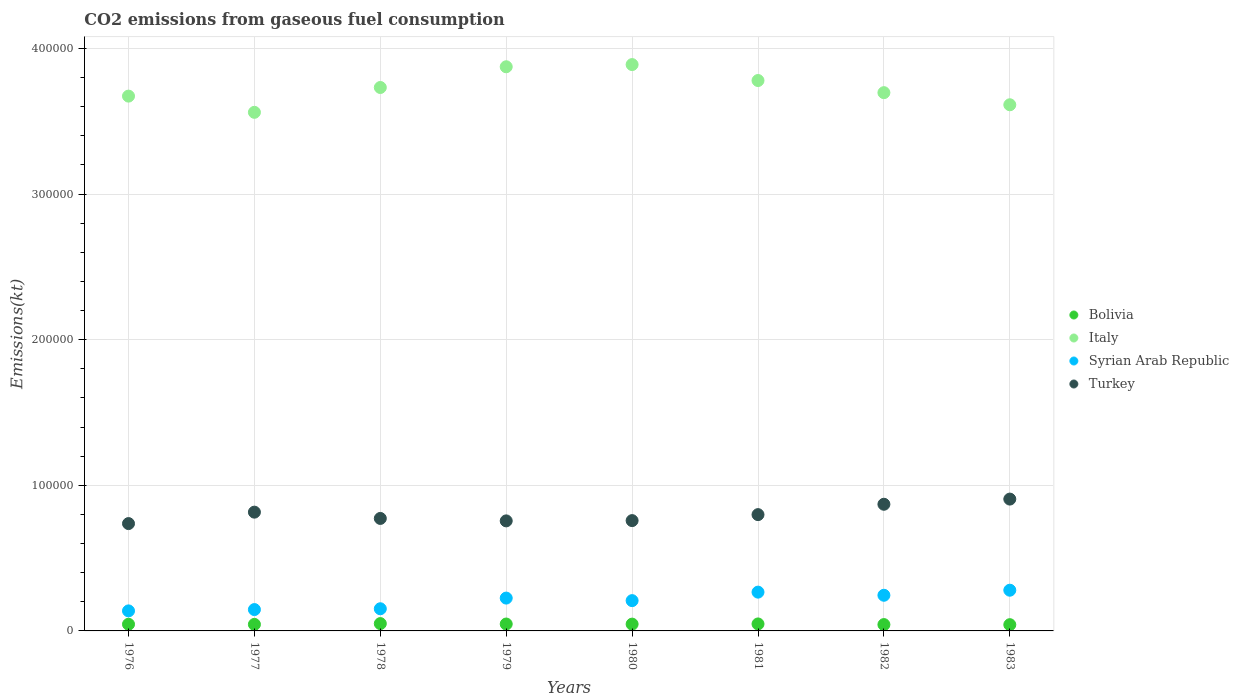How many different coloured dotlines are there?
Your response must be concise. 4. What is the amount of CO2 emitted in Italy in 1978?
Give a very brief answer. 3.73e+05. Across all years, what is the maximum amount of CO2 emitted in Syrian Arab Republic?
Your answer should be very brief. 2.80e+04. Across all years, what is the minimum amount of CO2 emitted in Syrian Arab Republic?
Ensure brevity in your answer.  1.38e+04. In which year was the amount of CO2 emitted in Bolivia maximum?
Provide a short and direct response. 1978. In which year was the amount of CO2 emitted in Syrian Arab Republic minimum?
Offer a very short reply. 1976. What is the total amount of CO2 emitted in Turkey in the graph?
Keep it short and to the point. 6.41e+05. What is the difference between the amount of CO2 emitted in Italy in 1976 and that in 1982?
Give a very brief answer. -2368.88. What is the difference between the amount of CO2 emitted in Turkey in 1976 and the amount of CO2 emitted in Syrian Arab Republic in 1980?
Your response must be concise. 5.29e+04. What is the average amount of CO2 emitted in Italy per year?
Ensure brevity in your answer.  3.73e+05. In the year 1976, what is the difference between the amount of CO2 emitted in Italy and amount of CO2 emitted in Turkey?
Provide a succinct answer. 2.94e+05. In how many years, is the amount of CO2 emitted in Italy greater than 160000 kt?
Your answer should be compact. 8. What is the ratio of the amount of CO2 emitted in Italy in 1976 to that in 1977?
Your answer should be compact. 1.03. Is the amount of CO2 emitted in Italy in 1978 less than that in 1980?
Provide a short and direct response. Yes. Is the difference between the amount of CO2 emitted in Italy in 1976 and 1982 greater than the difference between the amount of CO2 emitted in Turkey in 1976 and 1982?
Your answer should be very brief. Yes. What is the difference between the highest and the second highest amount of CO2 emitted in Bolivia?
Ensure brevity in your answer.  234.69. What is the difference between the highest and the lowest amount of CO2 emitted in Bolivia?
Offer a very short reply. 737.07. In how many years, is the amount of CO2 emitted in Bolivia greater than the average amount of CO2 emitted in Bolivia taken over all years?
Offer a terse response. 4. Is the sum of the amount of CO2 emitted in Bolivia in 1977 and 1983 greater than the maximum amount of CO2 emitted in Turkey across all years?
Your answer should be compact. No. Is it the case that in every year, the sum of the amount of CO2 emitted in Italy and amount of CO2 emitted in Turkey  is greater than the amount of CO2 emitted in Bolivia?
Provide a succinct answer. Yes. Does the amount of CO2 emitted in Syrian Arab Republic monotonically increase over the years?
Provide a succinct answer. No. Is the amount of CO2 emitted in Italy strictly less than the amount of CO2 emitted in Bolivia over the years?
Keep it short and to the point. No. How many dotlines are there?
Offer a very short reply. 4. What is the difference between two consecutive major ticks on the Y-axis?
Your answer should be very brief. 1.00e+05. Are the values on the major ticks of Y-axis written in scientific E-notation?
Your answer should be compact. No. Does the graph contain any zero values?
Give a very brief answer. No. How many legend labels are there?
Your answer should be compact. 4. What is the title of the graph?
Provide a short and direct response. CO2 emissions from gaseous fuel consumption. Does "Libya" appear as one of the legend labels in the graph?
Offer a terse response. No. What is the label or title of the Y-axis?
Your response must be concise. Emissions(kt). What is the Emissions(kt) in Bolivia in 1976?
Offer a very short reply. 4580.08. What is the Emissions(kt) of Italy in 1976?
Ensure brevity in your answer.  3.67e+05. What is the Emissions(kt) in Syrian Arab Republic in 1976?
Provide a succinct answer. 1.38e+04. What is the Emissions(kt) in Turkey in 1976?
Offer a terse response. 7.37e+04. What is the Emissions(kt) in Bolivia in 1977?
Ensure brevity in your answer.  4481.07. What is the Emissions(kt) of Italy in 1977?
Your response must be concise. 3.56e+05. What is the Emissions(kt) of Syrian Arab Republic in 1977?
Offer a very short reply. 1.47e+04. What is the Emissions(kt) of Turkey in 1977?
Your answer should be very brief. 8.16e+04. What is the Emissions(kt) of Bolivia in 1978?
Keep it short and to the point. 5027.46. What is the Emissions(kt) in Italy in 1978?
Provide a succinct answer. 3.73e+05. What is the Emissions(kt) of Syrian Arab Republic in 1978?
Make the answer very short. 1.52e+04. What is the Emissions(kt) in Turkey in 1978?
Provide a succinct answer. 7.73e+04. What is the Emissions(kt) of Bolivia in 1979?
Keep it short and to the point. 4737.76. What is the Emissions(kt) in Italy in 1979?
Ensure brevity in your answer.  3.87e+05. What is the Emissions(kt) of Syrian Arab Republic in 1979?
Offer a very short reply. 2.25e+04. What is the Emissions(kt) of Turkey in 1979?
Ensure brevity in your answer.  7.56e+04. What is the Emissions(kt) of Bolivia in 1980?
Offer a very short reply. 4668.09. What is the Emissions(kt) in Italy in 1980?
Your answer should be very brief. 3.89e+05. What is the Emissions(kt) in Syrian Arab Republic in 1980?
Provide a short and direct response. 2.08e+04. What is the Emissions(kt) in Turkey in 1980?
Provide a short and direct response. 7.58e+04. What is the Emissions(kt) in Bolivia in 1981?
Keep it short and to the point. 4792.77. What is the Emissions(kt) of Italy in 1981?
Your answer should be compact. 3.78e+05. What is the Emissions(kt) in Syrian Arab Republic in 1981?
Offer a terse response. 2.66e+04. What is the Emissions(kt) of Turkey in 1981?
Keep it short and to the point. 7.99e+04. What is the Emissions(kt) in Bolivia in 1982?
Provide a short and direct response. 4349.06. What is the Emissions(kt) in Italy in 1982?
Keep it short and to the point. 3.70e+05. What is the Emissions(kt) of Syrian Arab Republic in 1982?
Your answer should be compact. 2.45e+04. What is the Emissions(kt) in Turkey in 1982?
Ensure brevity in your answer.  8.70e+04. What is the Emissions(kt) of Bolivia in 1983?
Provide a succinct answer. 4290.39. What is the Emissions(kt) of Italy in 1983?
Provide a succinct answer. 3.61e+05. What is the Emissions(kt) in Syrian Arab Republic in 1983?
Your answer should be very brief. 2.80e+04. What is the Emissions(kt) of Turkey in 1983?
Your answer should be compact. 9.05e+04. Across all years, what is the maximum Emissions(kt) of Bolivia?
Keep it short and to the point. 5027.46. Across all years, what is the maximum Emissions(kt) of Italy?
Keep it short and to the point. 3.89e+05. Across all years, what is the maximum Emissions(kt) of Syrian Arab Republic?
Make the answer very short. 2.80e+04. Across all years, what is the maximum Emissions(kt) in Turkey?
Your response must be concise. 9.05e+04. Across all years, what is the minimum Emissions(kt) of Bolivia?
Provide a succinct answer. 4290.39. Across all years, what is the minimum Emissions(kt) in Italy?
Make the answer very short. 3.56e+05. Across all years, what is the minimum Emissions(kt) in Syrian Arab Republic?
Ensure brevity in your answer.  1.38e+04. Across all years, what is the minimum Emissions(kt) in Turkey?
Give a very brief answer. 7.37e+04. What is the total Emissions(kt) of Bolivia in the graph?
Give a very brief answer. 3.69e+04. What is the total Emissions(kt) in Italy in the graph?
Offer a very short reply. 2.98e+06. What is the total Emissions(kt) in Syrian Arab Republic in the graph?
Make the answer very short. 1.66e+05. What is the total Emissions(kt) in Turkey in the graph?
Your response must be concise. 6.41e+05. What is the difference between the Emissions(kt) in Bolivia in 1976 and that in 1977?
Ensure brevity in your answer.  99.01. What is the difference between the Emissions(kt) in Italy in 1976 and that in 1977?
Offer a very short reply. 1.11e+04. What is the difference between the Emissions(kt) in Syrian Arab Republic in 1976 and that in 1977?
Make the answer very short. -905.75. What is the difference between the Emissions(kt) in Turkey in 1976 and that in 1977?
Provide a succinct answer. -7851.05. What is the difference between the Emissions(kt) of Bolivia in 1976 and that in 1978?
Ensure brevity in your answer.  -447.37. What is the difference between the Emissions(kt) of Italy in 1976 and that in 1978?
Make the answer very short. -5922.2. What is the difference between the Emissions(kt) in Syrian Arab Republic in 1976 and that in 1978?
Your answer should be compact. -1463.13. What is the difference between the Emissions(kt) of Turkey in 1976 and that in 1978?
Provide a short and direct response. -3534.99. What is the difference between the Emissions(kt) of Bolivia in 1976 and that in 1979?
Your response must be concise. -157.68. What is the difference between the Emissions(kt) in Italy in 1976 and that in 1979?
Make the answer very short. -2.02e+04. What is the difference between the Emissions(kt) in Syrian Arab Republic in 1976 and that in 1979?
Your response must be concise. -8789.8. What is the difference between the Emissions(kt) in Turkey in 1976 and that in 1979?
Your answer should be compact. -1855.5. What is the difference between the Emissions(kt) of Bolivia in 1976 and that in 1980?
Your answer should be compact. -88.01. What is the difference between the Emissions(kt) of Italy in 1976 and that in 1980?
Ensure brevity in your answer.  -2.17e+04. What is the difference between the Emissions(kt) in Syrian Arab Republic in 1976 and that in 1980?
Your response must be concise. -7044.31. What is the difference between the Emissions(kt) of Turkey in 1976 and that in 1980?
Your answer should be very brief. -2042.52. What is the difference between the Emissions(kt) in Bolivia in 1976 and that in 1981?
Make the answer very short. -212.69. What is the difference between the Emissions(kt) of Italy in 1976 and that in 1981?
Your response must be concise. -1.07e+04. What is the difference between the Emissions(kt) of Syrian Arab Republic in 1976 and that in 1981?
Keep it short and to the point. -1.29e+04. What is the difference between the Emissions(kt) of Turkey in 1976 and that in 1981?
Provide a short and direct response. -6153.23. What is the difference between the Emissions(kt) in Bolivia in 1976 and that in 1982?
Make the answer very short. 231.02. What is the difference between the Emissions(kt) of Italy in 1976 and that in 1982?
Your answer should be compact. -2368.88. What is the difference between the Emissions(kt) in Syrian Arab Republic in 1976 and that in 1982?
Provide a short and direct response. -1.07e+04. What is the difference between the Emissions(kt) in Turkey in 1976 and that in 1982?
Give a very brief answer. -1.33e+04. What is the difference between the Emissions(kt) in Bolivia in 1976 and that in 1983?
Provide a short and direct response. 289.69. What is the difference between the Emissions(kt) in Italy in 1976 and that in 1983?
Offer a very short reply. 5947.87. What is the difference between the Emissions(kt) of Syrian Arab Republic in 1976 and that in 1983?
Offer a terse response. -1.42e+04. What is the difference between the Emissions(kt) of Turkey in 1976 and that in 1983?
Make the answer very short. -1.68e+04. What is the difference between the Emissions(kt) in Bolivia in 1977 and that in 1978?
Ensure brevity in your answer.  -546.38. What is the difference between the Emissions(kt) of Italy in 1977 and that in 1978?
Give a very brief answer. -1.71e+04. What is the difference between the Emissions(kt) of Syrian Arab Republic in 1977 and that in 1978?
Make the answer very short. -557.38. What is the difference between the Emissions(kt) in Turkey in 1977 and that in 1978?
Ensure brevity in your answer.  4316.06. What is the difference between the Emissions(kt) in Bolivia in 1977 and that in 1979?
Provide a short and direct response. -256.69. What is the difference between the Emissions(kt) of Italy in 1977 and that in 1979?
Offer a very short reply. -3.13e+04. What is the difference between the Emissions(kt) of Syrian Arab Republic in 1977 and that in 1979?
Provide a short and direct response. -7884.05. What is the difference between the Emissions(kt) of Turkey in 1977 and that in 1979?
Keep it short and to the point. 5995.55. What is the difference between the Emissions(kt) in Bolivia in 1977 and that in 1980?
Offer a terse response. -187.02. What is the difference between the Emissions(kt) in Italy in 1977 and that in 1980?
Your answer should be compact. -3.28e+04. What is the difference between the Emissions(kt) of Syrian Arab Republic in 1977 and that in 1980?
Your answer should be compact. -6138.56. What is the difference between the Emissions(kt) in Turkey in 1977 and that in 1980?
Keep it short and to the point. 5808.53. What is the difference between the Emissions(kt) of Bolivia in 1977 and that in 1981?
Your response must be concise. -311.69. What is the difference between the Emissions(kt) in Italy in 1977 and that in 1981?
Keep it short and to the point. -2.18e+04. What is the difference between the Emissions(kt) of Syrian Arab Republic in 1977 and that in 1981?
Your answer should be compact. -1.20e+04. What is the difference between the Emissions(kt) in Turkey in 1977 and that in 1981?
Provide a short and direct response. 1697.82. What is the difference between the Emissions(kt) of Bolivia in 1977 and that in 1982?
Your answer should be compact. 132.01. What is the difference between the Emissions(kt) of Italy in 1977 and that in 1982?
Your response must be concise. -1.35e+04. What is the difference between the Emissions(kt) of Syrian Arab Republic in 1977 and that in 1982?
Your answer should be compact. -9823.89. What is the difference between the Emissions(kt) of Turkey in 1977 and that in 1982?
Your answer should be very brief. -5416.16. What is the difference between the Emissions(kt) of Bolivia in 1977 and that in 1983?
Keep it short and to the point. 190.68. What is the difference between the Emissions(kt) of Italy in 1977 and that in 1983?
Your answer should be compact. -5188.81. What is the difference between the Emissions(kt) of Syrian Arab Republic in 1977 and that in 1983?
Make the answer very short. -1.33e+04. What is the difference between the Emissions(kt) in Turkey in 1977 and that in 1983?
Keep it short and to the point. -8969.48. What is the difference between the Emissions(kt) of Bolivia in 1978 and that in 1979?
Your answer should be compact. 289.69. What is the difference between the Emissions(kt) of Italy in 1978 and that in 1979?
Your answer should be very brief. -1.42e+04. What is the difference between the Emissions(kt) in Syrian Arab Republic in 1978 and that in 1979?
Offer a terse response. -7326.67. What is the difference between the Emissions(kt) of Turkey in 1978 and that in 1979?
Your answer should be compact. 1679.49. What is the difference between the Emissions(kt) of Bolivia in 1978 and that in 1980?
Make the answer very short. 359.37. What is the difference between the Emissions(kt) of Italy in 1978 and that in 1980?
Your response must be concise. -1.57e+04. What is the difference between the Emissions(kt) of Syrian Arab Republic in 1978 and that in 1980?
Your answer should be compact. -5581.17. What is the difference between the Emissions(kt) of Turkey in 1978 and that in 1980?
Provide a short and direct response. 1492.47. What is the difference between the Emissions(kt) in Bolivia in 1978 and that in 1981?
Offer a very short reply. 234.69. What is the difference between the Emissions(kt) of Italy in 1978 and that in 1981?
Make the answer very short. -4785.44. What is the difference between the Emissions(kt) in Syrian Arab Republic in 1978 and that in 1981?
Offer a very short reply. -1.14e+04. What is the difference between the Emissions(kt) of Turkey in 1978 and that in 1981?
Provide a short and direct response. -2618.24. What is the difference between the Emissions(kt) of Bolivia in 1978 and that in 1982?
Your answer should be very brief. 678.39. What is the difference between the Emissions(kt) in Italy in 1978 and that in 1982?
Your answer should be compact. 3553.32. What is the difference between the Emissions(kt) in Syrian Arab Republic in 1978 and that in 1982?
Provide a succinct answer. -9266.51. What is the difference between the Emissions(kt) of Turkey in 1978 and that in 1982?
Offer a terse response. -9732.22. What is the difference between the Emissions(kt) of Bolivia in 1978 and that in 1983?
Provide a succinct answer. 737.07. What is the difference between the Emissions(kt) of Italy in 1978 and that in 1983?
Ensure brevity in your answer.  1.19e+04. What is the difference between the Emissions(kt) in Syrian Arab Republic in 1978 and that in 1983?
Your answer should be very brief. -1.27e+04. What is the difference between the Emissions(kt) of Turkey in 1978 and that in 1983?
Offer a very short reply. -1.33e+04. What is the difference between the Emissions(kt) in Bolivia in 1979 and that in 1980?
Your answer should be very brief. 69.67. What is the difference between the Emissions(kt) of Italy in 1979 and that in 1980?
Your answer should be compact. -1503.47. What is the difference between the Emissions(kt) of Syrian Arab Republic in 1979 and that in 1980?
Offer a terse response. 1745.49. What is the difference between the Emissions(kt) in Turkey in 1979 and that in 1980?
Offer a very short reply. -187.02. What is the difference between the Emissions(kt) in Bolivia in 1979 and that in 1981?
Ensure brevity in your answer.  -55.01. What is the difference between the Emissions(kt) in Italy in 1979 and that in 1981?
Your response must be concise. 9446.19. What is the difference between the Emissions(kt) in Syrian Arab Republic in 1979 and that in 1981?
Offer a very short reply. -4088.7. What is the difference between the Emissions(kt) in Turkey in 1979 and that in 1981?
Give a very brief answer. -4297.72. What is the difference between the Emissions(kt) in Bolivia in 1979 and that in 1982?
Keep it short and to the point. 388.7. What is the difference between the Emissions(kt) in Italy in 1979 and that in 1982?
Keep it short and to the point. 1.78e+04. What is the difference between the Emissions(kt) in Syrian Arab Republic in 1979 and that in 1982?
Provide a succinct answer. -1939.84. What is the difference between the Emissions(kt) of Turkey in 1979 and that in 1982?
Ensure brevity in your answer.  -1.14e+04. What is the difference between the Emissions(kt) of Bolivia in 1979 and that in 1983?
Offer a very short reply. 447.37. What is the difference between the Emissions(kt) in Italy in 1979 and that in 1983?
Your response must be concise. 2.61e+04. What is the difference between the Emissions(kt) in Syrian Arab Republic in 1979 and that in 1983?
Offer a very short reply. -5412.49. What is the difference between the Emissions(kt) in Turkey in 1979 and that in 1983?
Offer a terse response. -1.50e+04. What is the difference between the Emissions(kt) in Bolivia in 1980 and that in 1981?
Your answer should be very brief. -124.68. What is the difference between the Emissions(kt) of Italy in 1980 and that in 1981?
Your answer should be very brief. 1.09e+04. What is the difference between the Emissions(kt) in Syrian Arab Republic in 1980 and that in 1981?
Ensure brevity in your answer.  -5834.2. What is the difference between the Emissions(kt) of Turkey in 1980 and that in 1981?
Offer a terse response. -4110.71. What is the difference between the Emissions(kt) of Bolivia in 1980 and that in 1982?
Provide a succinct answer. 319.03. What is the difference between the Emissions(kt) of Italy in 1980 and that in 1982?
Provide a succinct answer. 1.93e+04. What is the difference between the Emissions(kt) of Syrian Arab Republic in 1980 and that in 1982?
Your answer should be compact. -3685.34. What is the difference between the Emissions(kt) of Turkey in 1980 and that in 1982?
Offer a very short reply. -1.12e+04. What is the difference between the Emissions(kt) in Bolivia in 1980 and that in 1983?
Provide a succinct answer. 377.7. What is the difference between the Emissions(kt) of Italy in 1980 and that in 1983?
Ensure brevity in your answer.  2.76e+04. What is the difference between the Emissions(kt) of Syrian Arab Republic in 1980 and that in 1983?
Give a very brief answer. -7157.98. What is the difference between the Emissions(kt) in Turkey in 1980 and that in 1983?
Your response must be concise. -1.48e+04. What is the difference between the Emissions(kt) of Bolivia in 1981 and that in 1982?
Your answer should be very brief. 443.71. What is the difference between the Emissions(kt) of Italy in 1981 and that in 1982?
Offer a very short reply. 8338.76. What is the difference between the Emissions(kt) in Syrian Arab Republic in 1981 and that in 1982?
Your answer should be very brief. 2148.86. What is the difference between the Emissions(kt) in Turkey in 1981 and that in 1982?
Ensure brevity in your answer.  -7113.98. What is the difference between the Emissions(kt) of Bolivia in 1981 and that in 1983?
Make the answer very short. 502.38. What is the difference between the Emissions(kt) of Italy in 1981 and that in 1983?
Ensure brevity in your answer.  1.67e+04. What is the difference between the Emissions(kt) in Syrian Arab Republic in 1981 and that in 1983?
Ensure brevity in your answer.  -1323.79. What is the difference between the Emissions(kt) of Turkey in 1981 and that in 1983?
Provide a succinct answer. -1.07e+04. What is the difference between the Emissions(kt) in Bolivia in 1982 and that in 1983?
Keep it short and to the point. 58.67. What is the difference between the Emissions(kt) in Italy in 1982 and that in 1983?
Ensure brevity in your answer.  8316.76. What is the difference between the Emissions(kt) of Syrian Arab Republic in 1982 and that in 1983?
Ensure brevity in your answer.  -3472.65. What is the difference between the Emissions(kt) of Turkey in 1982 and that in 1983?
Keep it short and to the point. -3553.32. What is the difference between the Emissions(kt) in Bolivia in 1976 and the Emissions(kt) in Italy in 1977?
Offer a terse response. -3.52e+05. What is the difference between the Emissions(kt) of Bolivia in 1976 and the Emissions(kt) of Syrian Arab Republic in 1977?
Provide a short and direct response. -1.01e+04. What is the difference between the Emissions(kt) of Bolivia in 1976 and the Emissions(kt) of Turkey in 1977?
Offer a very short reply. -7.70e+04. What is the difference between the Emissions(kt) in Italy in 1976 and the Emissions(kt) in Syrian Arab Republic in 1977?
Offer a very short reply. 3.53e+05. What is the difference between the Emissions(kt) in Italy in 1976 and the Emissions(kt) in Turkey in 1977?
Give a very brief answer. 2.86e+05. What is the difference between the Emissions(kt) of Syrian Arab Republic in 1976 and the Emissions(kt) of Turkey in 1977?
Offer a very short reply. -6.78e+04. What is the difference between the Emissions(kt) of Bolivia in 1976 and the Emissions(kt) of Italy in 1978?
Offer a very short reply. -3.69e+05. What is the difference between the Emissions(kt) of Bolivia in 1976 and the Emissions(kt) of Syrian Arab Republic in 1978?
Your response must be concise. -1.06e+04. What is the difference between the Emissions(kt) in Bolivia in 1976 and the Emissions(kt) in Turkey in 1978?
Provide a succinct answer. -7.27e+04. What is the difference between the Emissions(kt) of Italy in 1976 and the Emissions(kt) of Syrian Arab Republic in 1978?
Your answer should be compact. 3.52e+05. What is the difference between the Emissions(kt) in Italy in 1976 and the Emissions(kt) in Turkey in 1978?
Make the answer very short. 2.90e+05. What is the difference between the Emissions(kt) of Syrian Arab Republic in 1976 and the Emissions(kt) of Turkey in 1978?
Offer a terse response. -6.35e+04. What is the difference between the Emissions(kt) in Bolivia in 1976 and the Emissions(kt) in Italy in 1979?
Make the answer very short. -3.83e+05. What is the difference between the Emissions(kt) of Bolivia in 1976 and the Emissions(kt) of Syrian Arab Republic in 1979?
Keep it short and to the point. -1.80e+04. What is the difference between the Emissions(kt) in Bolivia in 1976 and the Emissions(kt) in Turkey in 1979?
Offer a very short reply. -7.10e+04. What is the difference between the Emissions(kt) in Italy in 1976 and the Emissions(kt) in Syrian Arab Republic in 1979?
Your answer should be very brief. 3.45e+05. What is the difference between the Emissions(kt) in Italy in 1976 and the Emissions(kt) in Turkey in 1979?
Give a very brief answer. 2.92e+05. What is the difference between the Emissions(kt) in Syrian Arab Republic in 1976 and the Emissions(kt) in Turkey in 1979?
Provide a short and direct response. -6.18e+04. What is the difference between the Emissions(kt) in Bolivia in 1976 and the Emissions(kt) in Italy in 1980?
Your response must be concise. -3.84e+05. What is the difference between the Emissions(kt) of Bolivia in 1976 and the Emissions(kt) of Syrian Arab Republic in 1980?
Give a very brief answer. -1.62e+04. What is the difference between the Emissions(kt) of Bolivia in 1976 and the Emissions(kt) of Turkey in 1980?
Your response must be concise. -7.12e+04. What is the difference between the Emissions(kt) of Italy in 1976 and the Emissions(kt) of Syrian Arab Republic in 1980?
Offer a very short reply. 3.47e+05. What is the difference between the Emissions(kt) of Italy in 1976 and the Emissions(kt) of Turkey in 1980?
Offer a very short reply. 2.92e+05. What is the difference between the Emissions(kt) of Syrian Arab Republic in 1976 and the Emissions(kt) of Turkey in 1980?
Keep it short and to the point. -6.20e+04. What is the difference between the Emissions(kt) of Bolivia in 1976 and the Emissions(kt) of Italy in 1981?
Offer a very short reply. -3.73e+05. What is the difference between the Emissions(kt) of Bolivia in 1976 and the Emissions(kt) of Syrian Arab Republic in 1981?
Provide a succinct answer. -2.21e+04. What is the difference between the Emissions(kt) of Bolivia in 1976 and the Emissions(kt) of Turkey in 1981?
Offer a terse response. -7.53e+04. What is the difference between the Emissions(kt) of Italy in 1976 and the Emissions(kt) of Syrian Arab Republic in 1981?
Ensure brevity in your answer.  3.41e+05. What is the difference between the Emissions(kt) of Italy in 1976 and the Emissions(kt) of Turkey in 1981?
Give a very brief answer. 2.87e+05. What is the difference between the Emissions(kt) in Syrian Arab Republic in 1976 and the Emissions(kt) in Turkey in 1981?
Keep it short and to the point. -6.61e+04. What is the difference between the Emissions(kt) in Bolivia in 1976 and the Emissions(kt) in Italy in 1982?
Provide a short and direct response. -3.65e+05. What is the difference between the Emissions(kt) of Bolivia in 1976 and the Emissions(kt) of Syrian Arab Republic in 1982?
Your answer should be very brief. -1.99e+04. What is the difference between the Emissions(kt) in Bolivia in 1976 and the Emissions(kt) in Turkey in 1982?
Offer a terse response. -8.24e+04. What is the difference between the Emissions(kt) of Italy in 1976 and the Emissions(kt) of Syrian Arab Republic in 1982?
Offer a terse response. 3.43e+05. What is the difference between the Emissions(kt) in Italy in 1976 and the Emissions(kt) in Turkey in 1982?
Provide a succinct answer. 2.80e+05. What is the difference between the Emissions(kt) in Syrian Arab Republic in 1976 and the Emissions(kt) in Turkey in 1982?
Ensure brevity in your answer.  -7.32e+04. What is the difference between the Emissions(kt) in Bolivia in 1976 and the Emissions(kt) in Italy in 1983?
Offer a terse response. -3.57e+05. What is the difference between the Emissions(kt) in Bolivia in 1976 and the Emissions(kt) in Syrian Arab Republic in 1983?
Keep it short and to the point. -2.34e+04. What is the difference between the Emissions(kt) in Bolivia in 1976 and the Emissions(kt) in Turkey in 1983?
Offer a terse response. -8.60e+04. What is the difference between the Emissions(kt) in Italy in 1976 and the Emissions(kt) in Syrian Arab Republic in 1983?
Provide a succinct answer. 3.39e+05. What is the difference between the Emissions(kt) of Italy in 1976 and the Emissions(kt) of Turkey in 1983?
Provide a succinct answer. 2.77e+05. What is the difference between the Emissions(kt) in Syrian Arab Republic in 1976 and the Emissions(kt) in Turkey in 1983?
Provide a succinct answer. -7.68e+04. What is the difference between the Emissions(kt) in Bolivia in 1977 and the Emissions(kt) in Italy in 1978?
Your answer should be very brief. -3.69e+05. What is the difference between the Emissions(kt) in Bolivia in 1977 and the Emissions(kt) in Syrian Arab Republic in 1978?
Offer a very short reply. -1.07e+04. What is the difference between the Emissions(kt) of Bolivia in 1977 and the Emissions(kt) of Turkey in 1978?
Provide a succinct answer. -7.28e+04. What is the difference between the Emissions(kt) of Italy in 1977 and the Emissions(kt) of Syrian Arab Republic in 1978?
Offer a terse response. 3.41e+05. What is the difference between the Emissions(kt) in Italy in 1977 and the Emissions(kt) in Turkey in 1978?
Provide a short and direct response. 2.79e+05. What is the difference between the Emissions(kt) of Syrian Arab Republic in 1977 and the Emissions(kt) of Turkey in 1978?
Your response must be concise. -6.26e+04. What is the difference between the Emissions(kt) in Bolivia in 1977 and the Emissions(kt) in Italy in 1979?
Make the answer very short. -3.83e+05. What is the difference between the Emissions(kt) in Bolivia in 1977 and the Emissions(kt) in Syrian Arab Republic in 1979?
Your answer should be very brief. -1.81e+04. What is the difference between the Emissions(kt) of Bolivia in 1977 and the Emissions(kt) of Turkey in 1979?
Offer a terse response. -7.11e+04. What is the difference between the Emissions(kt) in Italy in 1977 and the Emissions(kt) in Syrian Arab Republic in 1979?
Your answer should be compact. 3.34e+05. What is the difference between the Emissions(kt) of Italy in 1977 and the Emissions(kt) of Turkey in 1979?
Keep it short and to the point. 2.81e+05. What is the difference between the Emissions(kt) of Syrian Arab Republic in 1977 and the Emissions(kt) of Turkey in 1979?
Your answer should be compact. -6.09e+04. What is the difference between the Emissions(kt) in Bolivia in 1977 and the Emissions(kt) in Italy in 1980?
Make the answer very short. -3.84e+05. What is the difference between the Emissions(kt) in Bolivia in 1977 and the Emissions(kt) in Syrian Arab Republic in 1980?
Your answer should be compact. -1.63e+04. What is the difference between the Emissions(kt) in Bolivia in 1977 and the Emissions(kt) in Turkey in 1980?
Make the answer very short. -7.13e+04. What is the difference between the Emissions(kt) in Italy in 1977 and the Emissions(kt) in Syrian Arab Republic in 1980?
Give a very brief answer. 3.35e+05. What is the difference between the Emissions(kt) of Italy in 1977 and the Emissions(kt) of Turkey in 1980?
Ensure brevity in your answer.  2.80e+05. What is the difference between the Emissions(kt) of Syrian Arab Republic in 1977 and the Emissions(kt) of Turkey in 1980?
Provide a succinct answer. -6.11e+04. What is the difference between the Emissions(kt) of Bolivia in 1977 and the Emissions(kt) of Italy in 1981?
Provide a short and direct response. -3.74e+05. What is the difference between the Emissions(kt) of Bolivia in 1977 and the Emissions(kt) of Syrian Arab Republic in 1981?
Provide a succinct answer. -2.22e+04. What is the difference between the Emissions(kt) in Bolivia in 1977 and the Emissions(kt) in Turkey in 1981?
Offer a very short reply. -7.54e+04. What is the difference between the Emissions(kt) of Italy in 1977 and the Emissions(kt) of Syrian Arab Republic in 1981?
Offer a terse response. 3.30e+05. What is the difference between the Emissions(kt) in Italy in 1977 and the Emissions(kt) in Turkey in 1981?
Make the answer very short. 2.76e+05. What is the difference between the Emissions(kt) in Syrian Arab Republic in 1977 and the Emissions(kt) in Turkey in 1981?
Your response must be concise. -6.52e+04. What is the difference between the Emissions(kt) of Bolivia in 1977 and the Emissions(kt) of Italy in 1982?
Provide a succinct answer. -3.65e+05. What is the difference between the Emissions(kt) in Bolivia in 1977 and the Emissions(kt) in Syrian Arab Republic in 1982?
Ensure brevity in your answer.  -2.00e+04. What is the difference between the Emissions(kt) of Bolivia in 1977 and the Emissions(kt) of Turkey in 1982?
Provide a succinct answer. -8.25e+04. What is the difference between the Emissions(kt) in Italy in 1977 and the Emissions(kt) in Syrian Arab Republic in 1982?
Give a very brief answer. 3.32e+05. What is the difference between the Emissions(kt) of Italy in 1977 and the Emissions(kt) of Turkey in 1982?
Provide a short and direct response. 2.69e+05. What is the difference between the Emissions(kt) of Syrian Arab Republic in 1977 and the Emissions(kt) of Turkey in 1982?
Your answer should be very brief. -7.23e+04. What is the difference between the Emissions(kt) in Bolivia in 1977 and the Emissions(kt) in Italy in 1983?
Keep it short and to the point. -3.57e+05. What is the difference between the Emissions(kt) of Bolivia in 1977 and the Emissions(kt) of Syrian Arab Republic in 1983?
Ensure brevity in your answer.  -2.35e+04. What is the difference between the Emissions(kt) in Bolivia in 1977 and the Emissions(kt) in Turkey in 1983?
Ensure brevity in your answer.  -8.61e+04. What is the difference between the Emissions(kt) in Italy in 1977 and the Emissions(kt) in Syrian Arab Republic in 1983?
Give a very brief answer. 3.28e+05. What is the difference between the Emissions(kt) in Italy in 1977 and the Emissions(kt) in Turkey in 1983?
Your response must be concise. 2.66e+05. What is the difference between the Emissions(kt) in Syrian Arab Republic in 1977 and the Emissions(kt) in Turkey in 1983?
Make the answer very short. -7.59e+04. What is the difference between the Emissions(kt) in Bolivia in 1978 and the Emissions(kt) in Italy in 1979?
Offer a very short reply. -3.82e+05. What is the difference between the Emissions(kt) in Bolivia in 1978 and the Emissions(kt) in Syrian Arab Republic in 1979?
Offer a very short reply. -1.75e+04. What is the difference between the Emissions(kt) of Bolivia in 1978 and the Emissions(kt) of Turkey in 1979?
Provide a succinct answer. -7.05e+04. What is the difference between the Emissions(kt) in Italy in 1978 and the Emissions(kt) in Syrian Arab Republic in 1979?
Give a very brief answer. 3.51e+05. What is the difference between the Emissions(kt) in Italy in 1978 and the Emissions(kt) in Turkey in 1979?
Your response must be concise. 2.98e+05. What is the difference between the Emissions(kt) of Syrian Arab Republic in 1978 and the Emissions(kt) of Turkey in 1979?
Make the answer very short. -6.04e+04. What is the difference between the Emissions(kt) of Bolivia in 1978 and the Emissions(kt) of Italy in 1980?
Provide a short and direct response. -3.84e+05. What is the difference between the Emissions(kt) of Bolivia in 1978 and the Emissions(kt) of Syrian Arab Republic in 1980?
Your response must be concise. -1.58e+04. What is the difference between the Emissions(kt) of Bolivia in 1978 and the Emissions(kt) of Turkey in 1980?
Your answer should be very brief. -7.07e+04. What is the difference between the Emissions(kt) in Italy in 1978 and the Emissions(kt) in Syrian Arab Republic in 1980?
Make the answer very short. 3.52e+05. What is the difference between the Emissions(kt) of Italy in 1978 and the Emissions(kt) of Turkey in 1980?
Offer a terse response. 2.97e+05. What is the difference between the Emissions(kt) of Syrian Arab Republic in 1978 and the Emissions(kt) of Turkey in 1980?
Your answer should be very brief. -6.05e+04. What is the difference between the Emissions(kt) in Bolivia in 1978 and the Emissions(kt) in Italy in 1981?
Ensure brevity in your answer.  -3.73e+05. What is the difference between the Emissions(kt) of Bolivia in 1978 and the Emissions(kt) of Syrian Arab Republic in 1981?
Provide a short and direct response. -2.16e+04. What is the difference between the Emissions(kt) of Bolivia in 1978 and the Emissions(kt) of Turkey in 1981?
Provide a succinct answer. -7.48e+04. What is the difference between the Emissions(kt) of Italy in 1978 and the Emissions(kt) of Syrian Arab Republic in 1981?
Offer a very short reply. 3.47e+05. What is the difference between the Emissions(kt) of Italy in 1978 and the Emissions(kt) of Turkey in 1981?
Provide a succinct answer. 2.93e+05. What is the difference between the Emissions(kt) in Syrian Arab Republic in 1978 and the Emissions(kt) in Turkey in 1981?
Offer a very short reply. -6.47e+04. What is the difference between the Emissions(kt) in Bolivia in 1978 and the Emissions(kt) in Italy in 1982?
Keep it short and to the point. -3.65e+05. What is the difference between the Emissions(kt) of Bolivia in 1978 and the Emissions(kt) of Syrian Arab Republic in 1982?
Offer a terse response. -1.95e+04. What is the difference between the Emissions(kt) in Bolivia in 1978 and the Emissions(kt) in Turkey in 1982?
Your answer should be compact. -8.20e+04. What is the difference between the Emissions(kt) in Italy in 1978 and the Emissions(kt) in Syrian Arab Republic in 1982?
Provide a short and direct response. 3.49e+05. What is the difference between the Emissions(kt) in Italy in 1978 and the Emissions(kt) in Turkey in 1982?
Keep it short and to the point. 2.86e+05. What is the difference between the Emissions(kt) of Syrian Arab Republic in 1978 and the Emissions(kt) of Turkey in 1982?
Make the answer very short. -7.18e+04. What is the difference between the Emissions(kt) in Bolivia in 1978 and the Emissions(kt) in Italy in 1983?
Ensure brevity in your answer.  -3.56e+05. What is the difference between the Emissions(kt) of Bolivia in 1978 and the Emissions(kt) of Syrian Arab Republic in 1983?
Offer a terse response. -2.29e+04. What is the difference between the Emissions(kt) of Bolivia in 1978 and the Emissions(kt) of Turkey in 1983?
Provide a short and direct response. -8.55e+04. What is the difference between the Emissions(kt) of Italy in 1978 and the Emissions(kt) of Syrian Arab Republic in 1983?
Your answer should be compact. 3.45e+05. What is the difference between the Emissions(kt) in Italy in 1978 and the Emissions(kt) in Turkey in 1983?
Make the answer very short. 2.83e+05. What is the difference between the Emissions(kt) in Syrian Arab Republic in 1978 and the Emissions(kt) in Turkey in 1983?
Provide a short and direct response. -7.53e+04. What is the difference between the Emissions(kt) in Bolivia in 1979 and the Emissions(kt) in Italy in 1980?
Keep it short and to the point. -3.84e+05. What is the difference between the Emissions(kt) of Bolivia in 1979 and the Emissions(kt) of Syrian Arab Republic in 1980?
Your answer should be very brief. -1.61e+04. What is the difference between the Emissions(kt) in Bolivia in 1979 and the Emissions(kt) in Turkey in 1980?
Your answer should be very brief. -7.10e+04. What is the difference between the Emissions(kt) in Italy in 1979 and the Emissions(kt) in Syrian Arab Republic in 1980?
Your answer should be very brief. 3.67e+05. What is the difference between the Emissions(kt) of Italy in 1979 and the Emissions(kt) of Turkey in 1980?
Make the answer very short. 3.12e+05. What is the difference between the Emissions(kt) in Syrian Arab Republic in 1979 and the Emissions(kt) in Turkey in 1980?
Offer a terse response. -5.32e+04. What is the difference between the Emissions(kt) in Bolivia in 1979 and the Emissions(kt) in Italy in 1981?
Offer a very short reply. -3.73e+05. What is the difference between the Emissions(kt) of Bolivia in 1979 and the Emissions(kt) of Syrian Arab Republic in 1981?
Offer a very short reply. -2.19e+04. What is the difference between the Emissions(kt) of Bolivia in 1979 and the Emissions(kt) of Turkey in 1981?
Provide a short and direct response. -7.51e+04. What is the difference between the Emissions(kt) of Italy in 1979 and the Emissions(kt) of Syrian Arab Republic in 1981?
Your response must be concise. 3.61e+05. What is the difference between the Emissions(kt) in Italy in 1979 and the Emissions(kt) in Turkey in 1981?
Offer a very short reply. 3.08e+05. What is the difference between the Emissions(kt) of Syrian Arab Republic in 1979 and the Emissions(kt) of Turkey in 1981?
Offer a terse response. -5.73e+04. What is the difference between the Emissions(kt) in Bolivia in 1979 and the Emissions(kt) in Italy in 1982?
Keep it short and to the point. -3.65e+05. What is the difference between the Emissions(kt) of Bolivia in 1979 and the Emissions(kt) of Syrian Arab Republic in 1982?
Your answer should be compact. -1.98e+04. What is the difference between the Emissions(kt) in Bolivia in 1979 and the Emissions(kt) in Turkey in 1982?
Offer a very short reply. -8.23e+04. What is the difference between the Emissions(kt) in Italy in 1979 and the Emissions(kt) in Syrian Arab Republic in 1982?
Provide a succinct answer. 3.63e+05. What is the difference between the Emissions(kt) of Italy in 1979 and the Emissions(kt) of Turkey in 1982?
Your response must be concise. 3.00e+05. What is the difference between the Emissions(kt) of Syrian Arab Republic in 1979 and the Emissions(kt) of Turkey in 1982?
Offer a terse response. -6.44e+04. What is the difference between the Emissions(kt) in Bolivia in 1979 and the Emissions(kt) in Italy in 1983?
Your answer should be very brief. -3.57e+05. What is the difference between the Emissions(kt) of Bolivia in 1979 and the Emissions(kt) of Syrian Arab Republic in 1983?
Keep it short and to the point. -2.32e+04. What is the difference between the Emissions(kt) of Bolivia in 1979 and the Emissions(kt) of Turkey in 1983?
Offer a terse response. -8.58e+04. What is the difference between the Emissions(kt) in Italy in 1979 and the Emissions(kt) in Syrian Arab Republic in 1983?
Provide a succinct answer. 3.60e+05. What is the difference between the Emissions(kt) in Italy in 1979 and the Emissions(kt) in Turkey in 1983?
Keep it short and to the point. 2.97e+05. What is the difference between the Emissions(kt) in Syrian Arab Republic in 1979 and the Emissions(kt) in Turkey in 1983?
Offer a very short reply. -6.80e+04. What is the difference between the Emissions(kt) in Bolivia in 1980 and the Emissions(kt) in Italy in 1981?
Give a very brief answer. -3.73e+05. What is the difference between the Emissions(kt) of Bolivia in 1980 and the Emissions(kt) of Syrian Arab Republic in 1981?
Provide a short and direct response. -2.20e+04. What is the difference between the Emissions(kt) in Bolivia in 1980 and the Emissions(kt) in Turkey in 1981?
Provide a succinct answer. -7.52e+04. What is the difference between the Emissions(kt) in Italy in 1980 and the Emissions(kt) in Syrian Arab Republic in 1981?
Offer a terse response. 3.62e+05. What is the difference between the Emissions(kt) in Italy in 1980 and the Emissions(kt) in Turkey in 1981?
Your answer should be compact. 3.09e+05. What is the difference between the Emissions(kt) in Syrian Arab Republic in 1980 and the Emissions(kt) in Turkey in 1981?
Your answer should be compact. -5.91e+04. What is the difference between the Emissions(kt) in Bolivia in 1980 and the Emissions(kt) in Italy in 1982?
Your answer should be compact. -3.65e+05. What is the difference between the Emissions(kt) of Bolivia in 1980 and the Emissions(kt) of Syrian Arab Republic in 1982?
Ensure brevity in your answer.  -1.98e+04. What is the difference between the Emissions(kt) in Bolivia in 1980 and the Emissions(kt) in Turkey in 1982?
Your answer should be compact. -8.23e+04. What is the difference between the Emissions(kt) of Italy in 1980 and the Emissions(kt) of Syrian Arab Republic in 1982?
Keep it short and to the point. 3.64e+05. What is the difference between the Emissions(kt) in Italy in 1980 and the Emissions(kt) in Turkey in 1982?
Provide a succinct answer. 3.02e+05. What is the difference between the Emissions(kt) in Syrian Arab Republic in 1980 and the Emissions(kt) in Turkey in 1982?
Provide a succinct answer. -6.62e+04. What is the difference between the Emissions(kt) in Bolivia in 1980 and the Emissions(kt) in Italy in 1983?
Give a very brief answer. -3.57e+05. What is the difference between the Emissions(kt) in Bolivia in 1980 and the Emissions(kt) in Syrian Arab Republic in 1983?
Make the answer very short. -2.33e+04. What is the difference between the Emissions(kt) of Bolivia in 1980 and the Emissions(kt) of Turkey in 1983?
Offer a very short reply. -8.59e+04. What is the difference between the Emissions(kt) in Italy in 1980 and the Emissions(kt) in Syrian Arab Republic in 1983?
Provide a short and direct response. 3.61e+05. What is the difference between the Emissions(kt) in Italy in 1980 and the Emissions(kt) in Turkey in 1983?
Offer a very short reply. 2.98e+05. What is the difference between the Emissions(kt) of Syrian Arab Republic in 1980 and the Emissions(kt) of Turkey in 1983?
Keep it short and to the point. -6.97e+04. What is the difference between the Emissions(kt) of Bolivia in 1981 and the Emissions(kt) of Italy in 1982?
Provide a short and direct response. -3.65e+05. What is the difference between the Emissions(kt) of Bolivia in 1981 and the Emissions(kt) of Syrian Arab Republic in 1982?
Give a very brief answer. -1.97e+04. What is the difference between the Emissions(kt) of Bolivia in 1981 and the Emissions(kt) of Turkey in 1982?
Provide a short and direct response. -8.22e+04. What is the difference between the Emissions(kt) in Italy in 1981 and the Emissions(kt) in Syrian Arab Republic in 1982?
Offer a terse response. 3.54e+05. What is the difference between the Emissions(kt) of Italy in 1981 and the Emissions(kt) of Turkey in 1982?
Make the answer very short. 2.91e+05. What is the difference between the Emissions(kt) in Syrian Arab Republic in 1981 and the Emissions(kt) in Turkey in 1982?
Offer a very short reply. -6.04e+04. What is the difference between the Emissions(kt) of Bolivia in 1981 and the Emissions(kt) of Italy in 1983?
Provide a succinct answer. -3.57e+05. What is the difference between the Emissions(kt) in Bolivia in 1981 and the Emissions(kt) in Syrian Arab Republic in 1983?
Ensure brevity in your answer.  -2.32e+04. What is the difference between the Emissions(kt) of Bolivia in 1981 and the Emissions(kt) of Turkey in 1983?
Offer a very short reply. -8.57e+04. What is the difference between the Emissions(kt) of Italy in 1981 and the Emissions(kt) of Syrian Arab Republic in 1983?
Give a very brief answer. 3.50e+05. What is the difference between the Emissions(kt) of Italy in 1981 and the Emissions(kt) of Turkey in 1983?
Keep it short and to the point. 2.87e+05. What is the difference between the Emissions(kt) of Syrian Arab Republic in 1981 and the Emissions(kt) of Turkey in 1983?
Your response must be concise. -6.39e+04. What is the difference between the Emissions(kt) of Bolivia in 1982 and the Emissions(kt) of Italy in 1983?
Your answer should be very brief. -3.57e+05. What is the difference between the Emissions(kt) in Bolivia in 1982 and the Emissions(kt) in Syrian Arab Republic in 1983?
Your answer should be very brief. -2.36e+04. What is the difference between the Emissions(kt) in Bolivia in 1982 and the Emissions(kt) in Turkey in 1983?
Provide a succinct answer. -8.62e+04. What is the difference between the Emissions(kt) in Italy in 1982 and the Emissions(kt) in Syrian Arab Republic in 1983?
Keep it short and to the point. 3.42e+05. What is the difference between the Emissions(kt) of Italy in 1982 and the Emissions(kt) of Turkey in 1983?
Ensure brevity in your answer.  2.79e+05. What is the difference between the Emissions(kt) of Syrian Arab Republic in 1982 and the Emissions(kt) of Turkey in 1983?
Keep it short and to the point. -6.61e+04. What is the average Emissions(kt) in Bolivia per year?
Your answer should be very brief. 4615.84. What is the average Emissions(kt) in Italy per year?
Your answer should be very brief. 3.73e+05. What is the average Emissions(kt) in Syrian Arab Republic per year?
Provide a short and direct response. 2.08e+04. What is the average Emissions(kt) in Turkey per year?
Your answer should be compact. 8.02e+04. In the year 1976, what is the difference between the Emissions(kt) of Bolivia and Emissions(kt) of Italy?
Your answer should be very brief. -3.63e+05. In the year 1976, what is the difference between the Emissions(kt) of Bolivia and Emissions(kt) of Syrian Arab Republic?
Offer a terse response. -9178.5. In the year 1976, what is the difference between the Emissions(kt) in Bolivia and Emissions(kt) in Turkey?
Your answer should be very brief. -6.91e+04. In the year 1976, what is the difference between the Emissions(kt) in Italy and Emissions(kt) in Syrian Arab Republic?
Your response must be concise. 3.54e+05. In the year 1976, what is the difference between the Emissions(kt) in Italy and Emissions(kt) in Turkey?
Provide a succinct answer. 2.94e+05. In the year 1976, what is the difference between the Emissions(kt) in Syrian Arab Republic and Emissions(kt) in Turkey?
Provide a short and direct response. -6.00e+04. In the year 1977, what is the difference between the Emissions(kt) of Bolivia and Emissions(kt) of Italy?
Your answer should be very brief. -3.52e+05. In the year 1977, what is the difference between the Emissions(kt) in Bolivia and Emissions(kt) in Syrian Arab Republic?
Provide a short and direct response. -1.02e+04. In the year 1977, what is the difference between the Emissions(kt) in Bolivia and Emissions(kt) in Turkey?
Offer a very short reply. -7.71e+04. In the year 1977, what is the difference between the Emissions(kt) of Italy and Emissions(kt) of Syrian Arab Republic?
Your response must be concise. 3.42e+05. In the year 1977, what is the difference between the Emissions(kt) in Italy and Emissions(kt) in Turkey?
Give a very brief answer. 2.75e+05. In the year 1977, what is the difference between the Emissions(kt) of Syrian Arab Republic and Emissions(kt) of Turkey?
Offer a very short reply. -6.69e+04. In the year 1978, what is the difference between the Emissions(kt) of Bolivia and Emissions(kt) of Italy?
Your answer should be compact. -3.68e+05. In the year 1978, what is the difference between the Emissions(kt) of Bolivia and Emissions(kt) of Syrian Arab Republic?
Keep it short and to the point. -1.02e+04. In the year 1978, what is the difference between the Emissions(kt) of Bolivia and Emissions(kt) of Turkey?
Give a very brief answer. -7.22e+04. In the year 1978, what is the difference between the Emissions(kt) in Italy and Emissions(kt) in Syrian Arab Republic?
Your response must be concise. 3.58e+05. In the year 1978, what is the difference between the Emissions(kt) in Italy and Emissions(kt) in Turkey?
Keep it short and to the point. 2.96e+05. In the year 1978, what is the difference between the Emissions(kt) of Syrian Arab Republic and Emissions(kt) of Turkey?
Make the answer very short. -6.20e+04. In the year 1979, what is the difference between the Emissions(kt) of Bolivia and Emissions(kt) of Italy?
Your response must be concise. -3.83e+05. In the year 1979, what is the difference between the Emissions(kt) of Bolivia and Emissions(kt) of Syrian Arab Republic?
Your response must be concise. -1.78e+04. In the year 1979, what is the difference between the Emissions(kt) in Bolivia and Emissions(kt) in Turkey?
Offer a very short reply. -7.08e+04. In the year 1979, what is the difference between the Emissions(kt) in Italy and Emissions(kt) in Syrian Arab Republic?
Make the answer very short. 3.65e+05. In the year 1979, what is the difference between the Emissions(kt) in Italy and Emissions(kt) in Turkey?
Provide a succinct answer. 3.12e+05. In the year 1979, what is the difference between the Emissions(kt) of Syrian Arab Republic and Emissions(kt) of Turkey?
Offer a terse response. -5.30e+04. In the year 1980, what is the difference between the Emissions(kt) of Bolivia and Emissions(kt) of Italy?
Offer a very short reply. -3.84e+05. In the year 1980, what is the difference between the Emissions(kt) in Bolivia and Emissions(kt) in Syrian Arab Republic?
Give a very brief answer. -1.61e+04. In the year 1980, what is the difference between the Emissions(kt) in Bolivia and Emissions(kt) in Turkey?
Your answer should be very brief. -7.11e+04. In the year 1980, what is the difference between the Emissions(kt) in Italy and Emissions(kt) in Syrian Arab Republic?
Your response must be concise. 3.68e+05. In the year 1980, what is the difference between the Emissions(kt) of Italy and Emissions(kt) of Turkey?
Keep it short and to the point. 3.13e+05. In the year 1980, what is the difference between the Emissions(kt) of Syrian Arab Republic and Emissions(kt) of Turkey?
Your answer should be very brief. -5.50e+04. In the year 1981, what is the difference between the Emissions(kt) in Bolivia and Emissions(kt) in Italy?
Your answer should be compact. -3.73e+05. In the year 1981, what is the difference between the Emissions(kt) in Bolivia and Emissions(kt) in Syrian Arab Republic?
Provide a succinct answer. -2.18e+04. In the year 1981, what is the difference between the Emissions(kt) in Bolivia and Emissions(kt) in Turkey?
Give a very brief answer. -7.51e+04. In the year 1981, what is the difference between the Emissions(kt) in Italy and Emissions(kt) in Syrian Arab Republic?
Ensure brevity in your answer.  3.51e+05. In the year 1981, what is the difference between the Emissions(kt) of Italy and Emissions(kt) of Turkey?
Offer a terse response. 2.98e+05. In the year 1981, what is the difference between the Emissions(kt) of Syrian Arab Republic and Emissions(kt) of Turkey?
Keep it short and to the point. -5.32e+04. In the year 1982, what is the difference between the Emissions(kt) in Bolivia and Emissions(kt) in Italy?
Provide a short and direct response. -3.65e+05. In the year 1982, what is the difference between the Emissions(kt) in Bolivia and Emissions(kt) in Syrian Arab Republic?
Ensure brevity in your answer.  -2.01e+04. In the year 1982, what is the difference between the Emissions(kt) in Bolivia and Emissions(kt) in Turkey?
Provide a succinct answer. -8.26e+04. In the year 1982, what is the difference between the Emissions(kt) in Italy and Emissions(kt) in Syrian Arab Republic?
Your answer should be compact. 3.45e+05. In the year 1982, what is the difference between the Emissions(kt) in Italy and Emissions(kt) in Turkey?
Give a very brief answer. 2.83e+05. In the year 1982, what is the difference between the Emissions(kt) in Syrian Arab Republic and Emissions(kt) in Turkey?
Make the answer very short. -6.25e+04. In the year 1983, what is the difference between the Emissions(kt) of Bolivia and Emissions(kt) of Italy?
Ensure brevity in your answer.  -3.57e+05. In the year 1983, what is the difference between the Emissions(kt) of Bolivia and Emissions(kt) of Syrian Arab Republic?
Your answer should be very brief. -2.37e+04. In the year 1983, what is the difference between the Emissions(kt) of Bolivia and Emissions(kt) of Turkey?
Provide a short and direct response. -8.63e+04. In the year 1983, what is the difference between the Emissions(kt) of Italy and Emissions(kt) of Syrian Arab Republic?
Offer a terse response. 3.33e+05. In the year 1983, what is the difference between the Emissions(kt) of Italy and Emissions(kt) of Turkey?
Provide a short and direct response. 2.71e+05. In the year 1983, what is the difference between the Emissions(kt) of Syrian Arab Republic and Emissions(kt) of Turkey?
Make the answer very short. -6.26e+04. What is the ratio of the Emissions(kt) of Bolivia in 1976 to that in 1977?
Your answer should be compact. 1.02. What is the ratio of the Emissions(kt) of Italy in 1976 to that in 1977?
Provide a succinct answer. 1.03. What is the ratio of the Emissions(kt) in Syrian Arab Republic in 1976 to that in 1977?
Your answer should be very brief. 0.94. What is the ratio of the Emissions(kt) in Turkey in 1976 to that in 1977?
Give a very brief answer. 0.9. What is the ratio of the Emissions(kt) of Bolivia in 1976 to that in 1978?
Offer a very short reply. 0.91. What is the ratio of the Emissions(kt) of Italy in 1976 to that in 1978?
Ensure brevity in your answer.  0.98. What is the ratio of the Emissions(kt) of Syrian Arab Republic in 1976 to that in 1978?
Provide a succinct answer. 0.9. What is the ratio of the Emissions(kt) in Turkey in 1976 to that in 1978?
Your answer should be compact. 0.95. What is the ratio of the Emissions(kt) of Bolivia in 1976 to that in 1979?
Make the answer very short. 0.97. What is the ratio of the Emissions(kt) of Italy in 1976 to that in 1979?
Your response must be concise. 0.95. What is the ratio of the Emissions(kt) in Syrian Arab Republic in 1976 to that in 1979?
Your answer should be compact. 0.61. What is the ratio of the Emissions(kt) of Turkey in 1976 to that in 1979?
Give a very brief answer. 0.98. What is the ratio of the Emissions(kt) of Bolivia in 1976 to that in 1980?
Your answer should be very brief. 0.98. What is the ratio of the Emissions(kt) of Italy in 1976 to that in 1980?
Keep it short and to the point. 0.94. What is the ratio of the Emissions(kt) of Syrian Arab Republic in 1976 to that in 1980?
Give a very brief answer. 0.66. What is the ratio of the Emissions(kt) in Bolivia in 1976 to that in 1981?
Provide a short and direct response. 0.96. What is the ratio of the Emissions(kt) in Italy in 1976 to that in 1981?
Ensure brevity in your answer.  0.97. What is the ratio of the Emissions(kt) of Syrian Arab Republic in 1976 to that in 1981?
Make the answer very short. 0.52. What is the ratio of the Emissions(kt) of Turkey in 1976 to that in 1981?
Your answer should be compact. 0.92. What is the ratio of the Emissions(kt) of Bolivia in 1976 to that in 1982?
Keep it short and to the point. 1.05. What is the ratio of the Emissions(kt) in Italy in 1976 to that in 1982?
Your answer should be very brief. 0.99. What is the ratio of the Emissions(kt) in Syrian Arab Republic in 1976 to that in 1982?
Offer a very short reply. 0.56. What is the ratio of the Emissions(kt) of Turkey in 1976 to that in 1982?
Provide a succinct answer. 0.85. What is the ratio of the Emissions(kt) of Bolivia in 1976 to that in 1983?
Offer a very short reply. 1.07. What is the ratio of the Emissions(kt) in Italy in 1976 to that in 1983?
Ensure brevity in your answer.  1.02. What is the ratio of the Emissions(kt) of Syrian Arab Republic in 1976 to that in 1983?
Keep it short and to the point. 0.49. What is the ratio of the Emissions(kt) of Turkey in 1976 to that in 1983?
Give a very brief answer. 0.81. What is the ratio of the Emissions(kt) in Bolivia in 1977 to that in 1978?
Keep it short and to the point. 0.89. What is the ratio of the Emissions(kt) of Italy in 1977 to that in 1978?
Give a very brief answer. 0.95. What is the ratio of the Emissions(kt) in Syrian Arab Republic in 1977 to that in 1978?
Provide a short and direct response. 0.96. What is the ratio of the Emissions(kt) in Turkey in 1977 to that in 1978?
Provide a short and direct response. 1.06. What is the ratio of the Emissions(kt) in Bolivia in 1977 to that in 1979?
Offer a very short reply. 0.95. What is the ratio of the Emissions(kt) in Italy in 1977 to that in 1979?
Give a very brief answer. 0.92. What is the ratio of the Emissions(kt) of Syrian Arab Republic in 1977 to that in 1979?
Provide a succinct answer. 0.65. What is the ratio of the Emissions(kt) of Turkey in 1977 to that in 1979?
Your response must be concise. 1.08. What is the ratio of the Emissions(kt) in Bolivia in 1977 to that in 1980?
Give a very brief answer. 0.96. What is the ratio of the Emissions(kt) in Italy in 1977 to that in 1980?
Provide a short and direct response. 0.92. What is the ratio of the Emissions(kt) in Syrian Arab Republic in 1977 to that in 1980?
Keep it short and to the point. 0.7. What is the ratio of the Emissions(kt) in Turkey in 1977 to that in 1980?
Make the answer very short. 1.08. What is the ratio of the Emissions(kt) of Bolivia in 1977 to that in 1981?
Your answer should be very brief. 0.94. What is the ratio of the Emissions(kt) of Italy in 1977 to that in 1981?
Give a very brief answer. 0.94. What is the ratio of the Emissions(kt) of Syrian Arab Republic in 1977 to that in 1981?
Your response must be concise. 0.55. What is the ratio of the Emissions(kt) in Turkey in 1977 to that in 1981?
Provide a succinct answer. 1.02. What is the ratio of the Emissions(kt) of Bolivia in 1977 to that in 1982?
Offer a very short reply. 1.03. What is the ratio of the Emissions(kt) in Italy in 1977 to that in 1982?
Your answer should be compact. 0.96. What is the ratio of the Emissions(kt) in Syrian Arab Republic in 1977 to that in 1982?
Offer a very short reply. 0.6. What is the ratio of the Emissions(kt) in Turkey in 1977 to that in 1982?
Your answer should be very brief. 0.94. What is the ratio of the Emissions(kt) in Bolivia in 1977 to that in 1983?
Your answer should be compact. 1.04. What is the ratio of the Emissions(kt) of Italy in 1977 to that in 1983?
Provide a succinct answer. 0.99. What is the ratio of the Emissions(kt) in Syrian Arab Republic in 1977 to that in 1983?
Keep it short and to the point. 0.52. What is the ratio of the Emissions(kt) in Turkey in 1977 to that in 1983?
Give a very brief answer. 0.9. What is the ratio of the Emissions(kt) in Bolivia in 1978 to that in 1979?
Ensure brevity in your answer.  1.06. What is the ratio of the Emissions(kt) of Italy in 1978 to that in 1979?
Make the answer very short. 0.96. What is the ratio of the Emissions(kt) of Syrian Arab Republic in 1978 to that in 1979?
Make the answer very short. 0.68. What is the ratio of the Emissions(kt) in Turkey in 1978 to that in 1979?
Give a very brief answer. 1.02. What is the ratio of the Emissions(kt) in Bolivia in 1978 to that in 1980?
Offer a terse response. 1.08. What is the ratio of the Emissions(kt) of Italy in 1978 to that in 1980?
Ensure brevity in your answer.  0.96. What is the ratio of the Emissions(kt) in Syrian Arab Republic in 1978 to that in 1980?
Give a very brief answer. 0.73. What is the ratio of the Emissions(kt) of Turkey in 1978 to that in 1980?
Offer a very short reply. 1.02. What is the ratio of the Emissions(kt) in Bolivia in 1978 to that in 1981?
Your response must be concise. 1.05. What is the ratio of the Emissions(kt) in Italy in 1978 to that in 1981?
Offer a terse response. 0.99. What is the ratio of the Emissions(kt) of Turkey in 1978 to that in 1981?
Your answer should be compact. 0.97. What is the ratio of the Emissions(kt) in Bolivia in 1978 to that in 1982?
Keep it short and to the point. 1.16. What is the ratio of the Emissions(kt) of Italy in 1978 to that in 1982?
Provide a succinct answer. 1.01. What is the ratio of the Emissions(kt) of Syrian Arab Republic in 1978 to that in 1982?
Give a very brief answer. 0.62. What is the ratio of the Emissions(kt) in Turkey in 1978 to that in 1982?
Your answer should be compact. 0.89. What is the ratio of the Emissions(kt) of Bolivia in 1978 to that in 1983?
Ensure brevity in your answer.  1.17. What is the ratio of the Emissions(kt) of Italy in 1978 to that in 1983?
Make the answer very short. 1.03. What is the ratio of the Emissions(kt) of Syrian Arab Republic in 1978 to that in 1983?
Your response must be concise. 0.54. What is the ratio of the Emissions(kt) of Turkey in 1978 to that in 1983?
Make the answer very short. 0.85. What is the ratio of the Emissions(kt) of Bolivia in 1979 to that in 1980?
Your answer should be very brief. 1.01. What is the ratio of the Emissions(kt) in Italy in 1979 to that in 1980?
Make the answer very short. 1. What is the ratio of the Emissions(kt) of Syrian Arab Republic in 1979 to that in 1980?
Provide a short and direct response. 1.08. What is the ratio of the Emissions(kt) in Bolivia in 1979 to that in 1981?
Offer a terse response. 0.99. What is the ratio of the Emissions(kt) in Syrian Arab Republic in 1979 to that in 1981?
Provide a short and direct response. 0.85. What is the ratio of the Emissions(kt) of Turkey in 1979 to that in 1981?
Offer a very short reply. 0.95. What is the ratio of the Emissions(kt) of Bolivia in 1979 to that in 1982?
Give a very brief answer. 1.09. What is the ratio of the Emissions(kt) of Italy in 1979 to that in 1982?
Give a very brief answer. 1.05. What is the ratio of the Emissions(kt) of Syrian Arab Republic in 1979 to that in 1982?
Ensure brevity in your answer.  0.92. What is the ratio of the Emissions(kt) in Turkey in 1979 to that in 1982?
Your answer should be compact. 0.87. What is the ratio of the Emissions(kt) of Bolivia in 1979 to that in 1983?
Your answer should be very brief. 1.1. What is the ratio of the Emissions(kt) in Italy in 1979 to that in 1983?
Provide a succinct answer. 1.07. What is the ratio of the Emissions(kt) in Syrian Arab Republic in 1979 to that in 1983?
Your answer should be compact. 0.81. What is the ratio of the Emissions(kt) in Turkey in 1979 to that in 1983?
Your response must be concise. 0.83. What is the ratio of the Emissions(kt) of Bolivia in 1980 to that in 1981?
Ensure brevity in your answer.  0.97. What is the ratio of the Emissions(kt) in Italy in 1980 to that in 1981?
Keep it short and to the point. 1.03. What is the ratio of the Emissions(kt) in Syrian Arab Republic in 1980 to that in 1981?
Give a very brief answer. 0.78. What is the ratio of the Emissions(kt) in Turkey in 1980 to that in 1981?
Provide a succinct answer. 0.95. What is the ratio of the Emissions(kt) of Bolivia in 1980 to that in 1982?
Provide a succinct answer. 1.07. What is the ratio of the Emissions(kt) of Italy in 1980 to that in 1982?
Keep it short and to the point. 1.05. What is the ratio of the Emissions(kt) of Syrian Arab Republic in 1980 to that in 1982?
Offer a terse response. 0.85. What is the ratio of the Emissions(kt) in Turkey in 1980 to that in 1982?
Your answer should be compact. 0.87. What is the ratio of the Emissions(kt) of Bolivia in 1980 to that in 1983?
Give a very brief answer. 1.09. What is the ratio of the Emissions(kt) in Italy in 1980 to that in 1983?
Give a very brief answer. 1.08. What is the ratio of the Emissions(kt) in Syrian Arab Republic in 1980 to that in 1983?
Provide a succinct answer. 0.74. What is the ratio of the Emissions(kt) in Turkey in 1980 to that in 1983?
Your answer should be very brief. 0.84. What is the ratio of the Emissions(kt) in Bolivia in 1981 to that in 1982?
Your response must be concise. 1.1. What is the ratio of the Emissions(kt) in Italy in 1981 to that in 1982?
Your answer should be very brief. 1.02. What is the ratio of the Emissions(kt) of Syrian Arab Republic in 1981 to that in 1982?
Your answer should be compact. 1.09. What is the ratio of the Emissions(kt) of Turkey in 1981 to that in 1982?
Offer a terse response. 0.92. What is the ratio of the Emissions(kt) in Bolivia in 1981 to that in 1983?
Provide a succinct answer. 1.12. What is the ratio of the Emissions(kt) of Italy in 1981 to that in 1983?
Give a very brief answer. 1.05. What is the ratio of the Emissions(kt) of Syrian Arab Republic in 1981 to that in 1983?
Ensure brevity in your answer.  0.95. What is the ratio of the Emissions(kt) of Turkey in 1981 to that in 1983?
Your answer should be compact. 0.88. What is the ratio of the Emissions(kt) in Bolivia in 1982 to that in 1983?
Provide a succinct answer. 1.01. What is the ratio of the Emissions(kt) in Italy in 1982 to that in 1983?
Provide a succinct answer. 1.02. What is the ratio of the Emissions(kt) of Syrian Arab Republic in 1982 to that in 1983?
Give a very brief answer. 0.88. What is the ratio of the Emissions(kt) in Turkey in 1982 to that in 1983?
Offer a terse response. 0.96. What is the difference between the highest and the second highest Emissions(kt) of Bolivia?
Provide a succinct answer. 234.69. What is the difference between the highest and the second highest Emissions(kt) in Italy?
Your response must be concise. 1503.47. What is the difference between the highest and the second highest Emissions(kt) of Syrian Arab Republic?
Provide a succinct answer. 1323.79. What is the difference between the highest and the second highest Emissions(kt) of Turkey?
Your answer should be compact. 3553.32. What is the difference between the highest and the lowest Emissions(kt) of Bolivia?
Your response must be concise. 737.07. What is the difference between the highest and the lowest Emissions(kt) of Italy?
Give a very brief answer. 3.28e+04. What is the difference between the highest and the lowest Emissions(kt) in Syrian Arab Republic?
Keep it short and to the point. 1.42e+04. What is the difference between the highest and the lowest Emissions(kt) in Turkey?
Make the answer very short. 1.68e+04. 